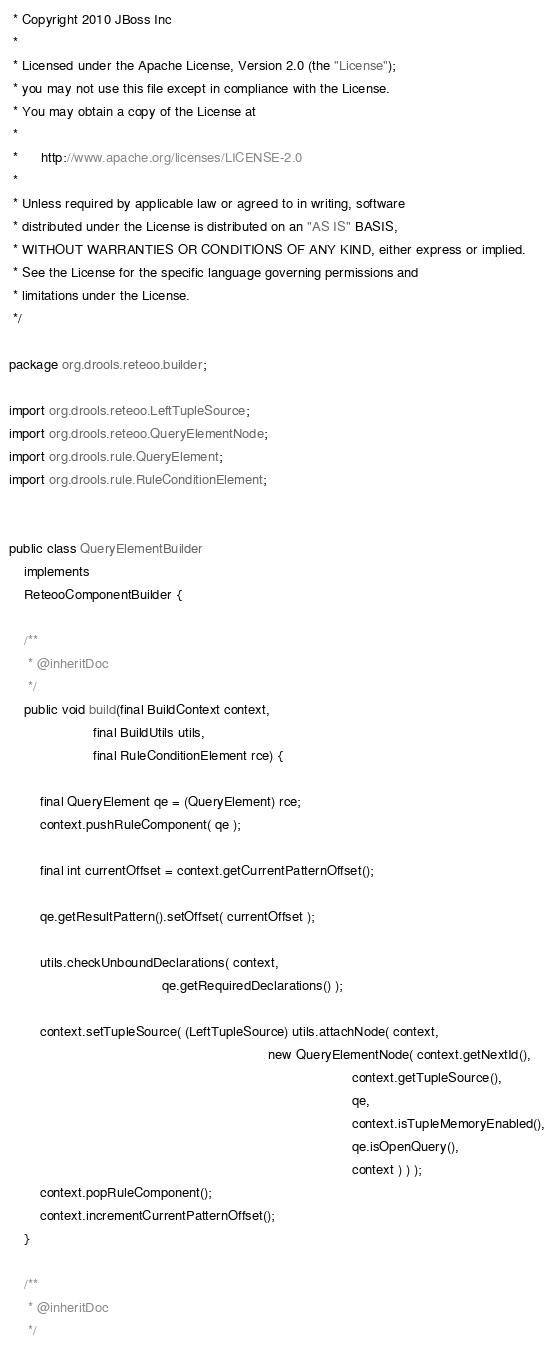Convert code to text. <code><loc_0><loc_0><loc_500><loc_500><_Java_> * Copyright 2010 JBoss Inc
 *
 * Licensed under the Apache License, Version 2.0 (the "License");
 * you may not use this file except in compliance with the License.
 * You may obtain a copy of the License at
 *
 *      http://www.apache.org/licenses/LICENSE-2.0
 *
 * Unless required by applicable law or agreed to in writing, software
 * distributed under the License is distributed on an "AS IS" BASIS,
 * WITHOUT WARRANTIES OR CONDITIONS OF ANY KIND, either express or implied.
 * See the License for the specific language governing permissions and
 * limitations under the License.
 */

package org.drools.reteoo.builder;

import org.drools.reteoo.LeftTupleSource;
import org.drools.reteoo.QueryElementNode;
import org.drools.rule.QueryElement;
import org.drools.rule.RuleConditionElement;


public class QueryElementBuilder
    implements
    ReteooComponentBuilder {

    /**
     * @inheritDoc
     */
    public void build(final BuildContext context,
                      final BuildUtils utils,
                      final RuleConditionElement rce) {

        final QueryElement qe = (QueryElement) rce;
        context.pushRuleComponent( qe );
        
        final int currentOffset = context.getCurrentPatternOffset();
        
        qe.getResultPattern().setOffset( currentOffset );
        
        utils.checkUnboundDeclarations( context,
                                        qe.getRequiredDeclarations() );

        context.setTupleSource( (LeftTupleSource) utils.attachNode( context,
                                                                    new QueryElementNode( context.getNextId(),
                                                                                          context.getTupleSource(),
                                                                                          qe,
                                                                                          context.isTupleMemoryEnabled(),
                                                                                          qe.isOpenQuery(),
                                                                                          context ) ) );
        context.popRuleComponent();
        context.incrementCurrentPatternOffset();
    }

    /**
     * @inheritDoc
     */</code> 